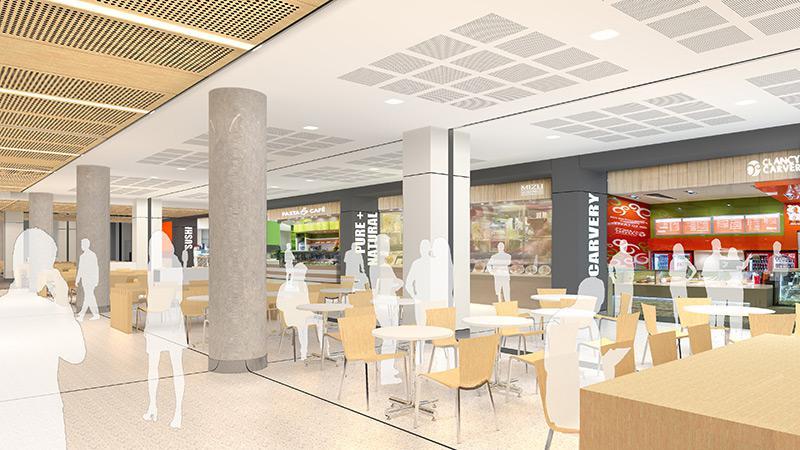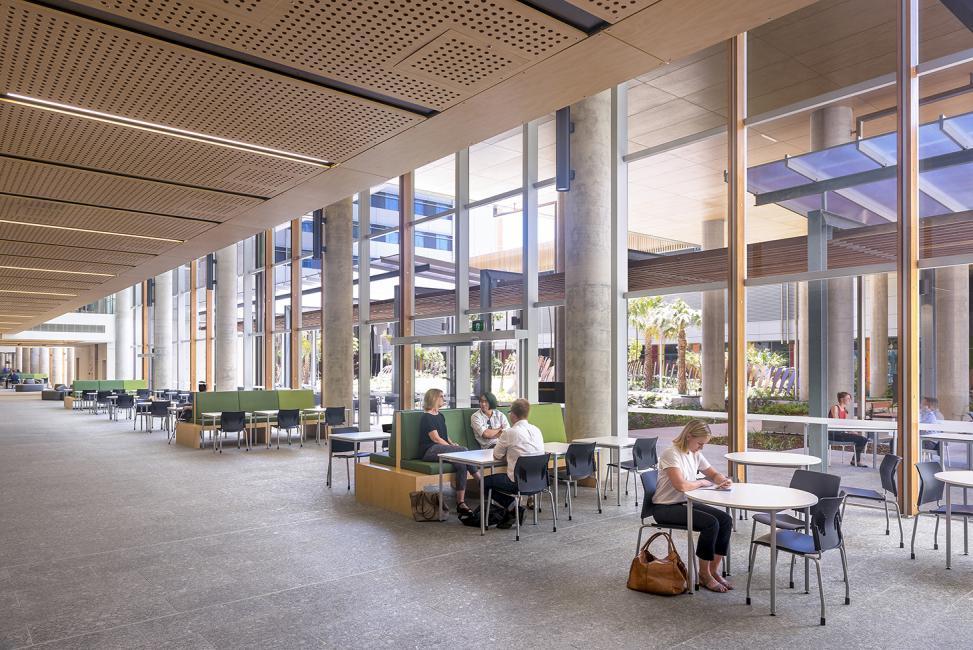The first image is the image on the left, the second image is the image on the right. Analyze the images presented: Is the assertion "In at least one image, there is a total of two people." valid? Answer yes or no. No. The first image is the image on the left, the second image is the image on the right. Examine the images to the left and right. Is the description "There are people sitting." accurate? Answer yes or no. Yes. 